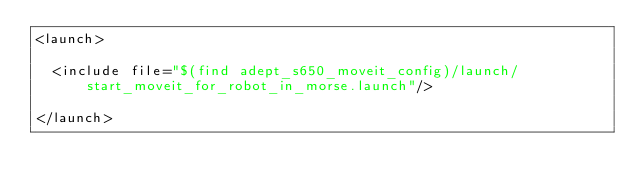<code> <loc_0><loc_0><loc_500><loc_500><_XML_><launch>

  <include file="$(find adept_s650_moveit_config)/launch/start_moveit_for_robot_in_morse.launch"/>
                  
</launch>
</code> 